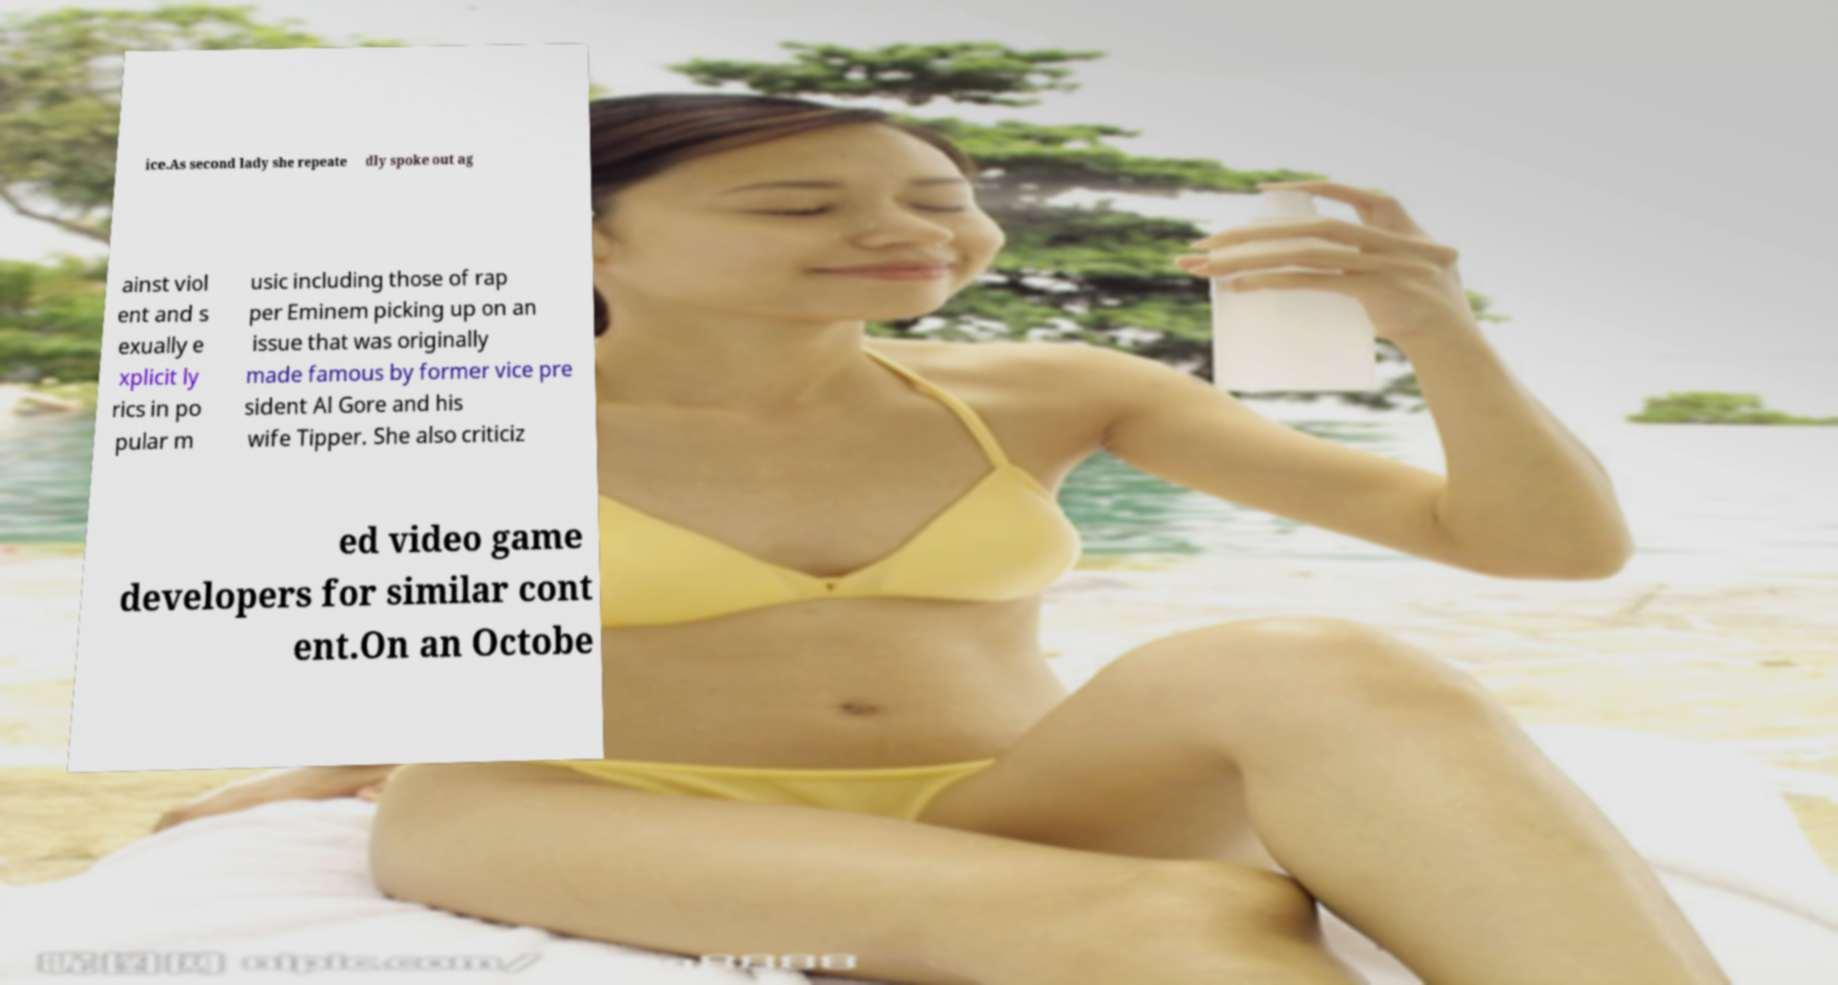There's text embedded in this image that I need extracted. Can you transcribe it verbatim? ice.As second lady she repeate dly spoke out ag ainst viol ent and s exually e xplicit ly rics in po pular m usic including those of rap per Eminem picking up on an issue that was originally made famous by former vice pre sident Al Gore and his wife Tipper. She also criticiz ed video game developers for similar cont ent.On an Octobe 